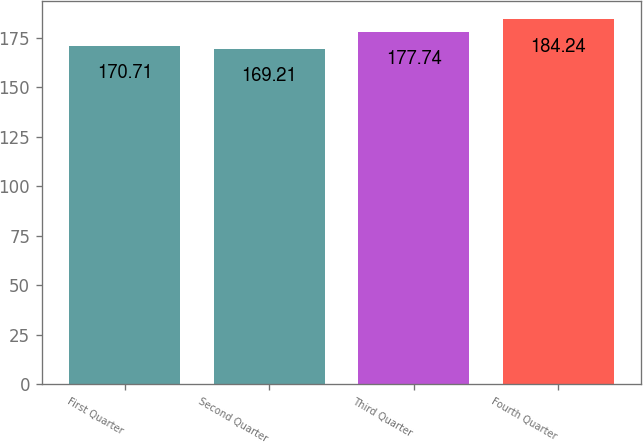Convert chart. <chart><loc_0><loc_0><loc_500><loc_500><bar_chart><fcel>First Quarter<fcel>Second Quarter<fcel>Third Quarter<fcel>Fourth Quarter<nl><fcel>170.71<fcel>169.21<fcel>177.74<fcel>184.24<nl></chart> 